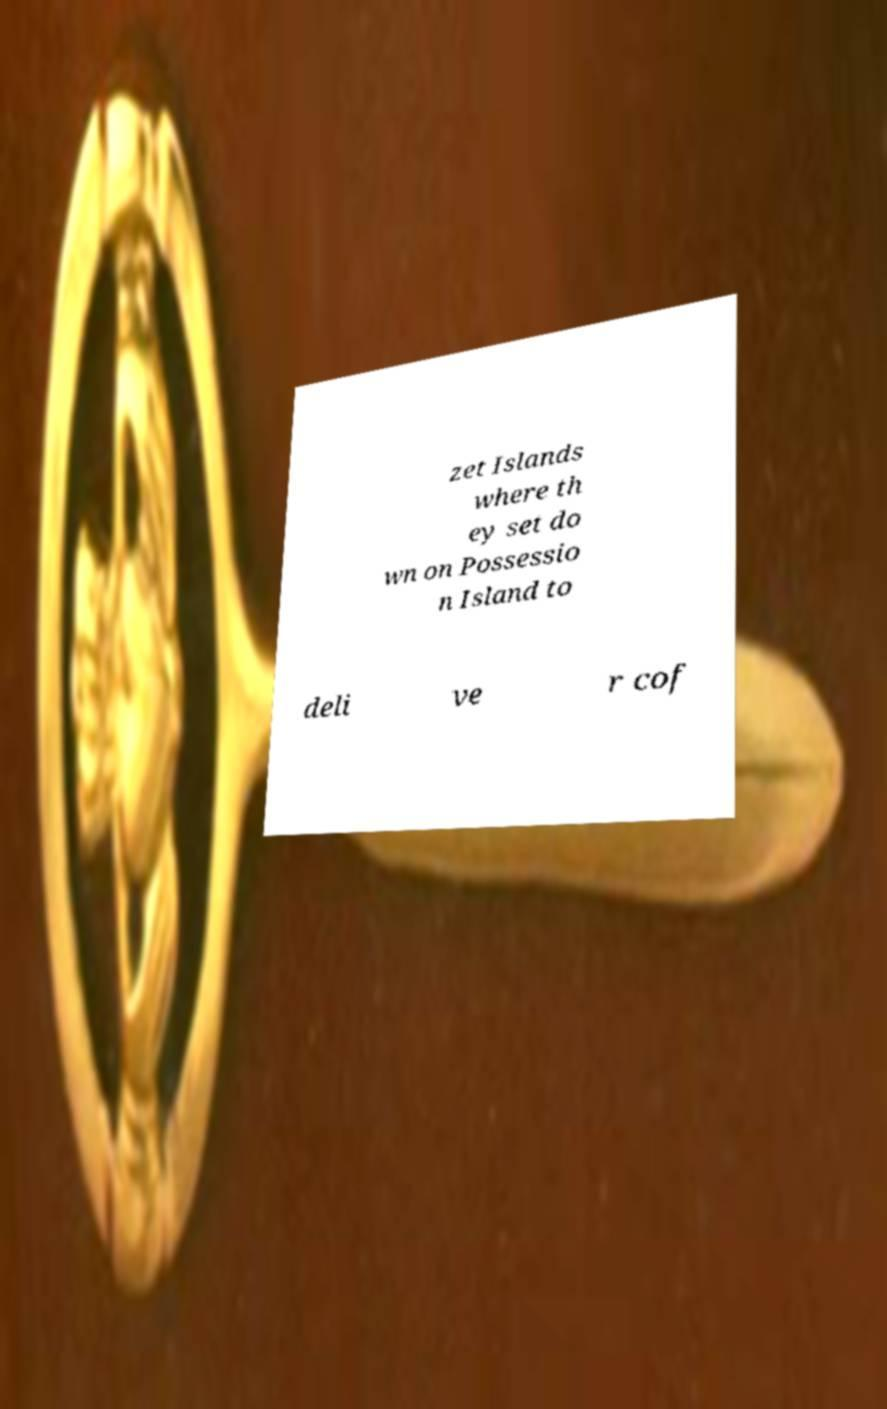Please identify and transcribe the text found in this image. zet Islands where th ey set do wn on Possessio n Island to deli ve r cof 